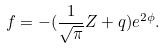<formula> <loc_0><loc_0><loc_500><loc_500>f = - ( \frac { 1 } { \sqrt { \pi } } Z + q ) e ^ { 2 \phi } .</formula> 